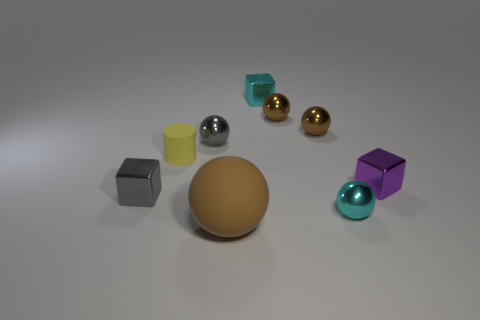How many other things are there of the same material as the big brown object?
Offer a terse response. 1. There is a purple object that is the same material as the cyan sphere; what is its shape?
Provide a succinct answer. Cube. Is there any other thing that has the same color as the cylinder?
Offer a terse response. No. Is the number of small rubber cylinders that are in front of the gray metal cube greater than the number of tiny objects?
Provide a succinct answer. No. Is the shape of the yellow thing the same as the cyan shiny thing that is in front of the gray metal cube?
Ensure brevity in your answer.  No. What number of cylinders have the same size as the brown matte ball?
Your response must be concise. 0. What number of small brown shiny objects are to the right of the small metal block on the left side of the tiny cyan object that is left of the cyan sphere?
Your answer should be compact. 2. Is the number of tiny gray shiny cubes that are on the right side of the tiny purple shiny cube the same as the number of purple objects that are in front of the gray ball?
Keep it short and to the point. No. What number of brown metallic things are the same shape as the tiny purple object?
Offer a very short reply. 0. Is there a big brown object that has the same material as the small cyan block?
Provide a short and direct response. No. 